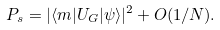<formula> <loc_0><loc_0><loc_500><loc_500>P _ { s } = | \langle m | U _ { G } | \psi \rangle | ^ { 2 } + O ( { 1 } / { N } ) .</formula> 